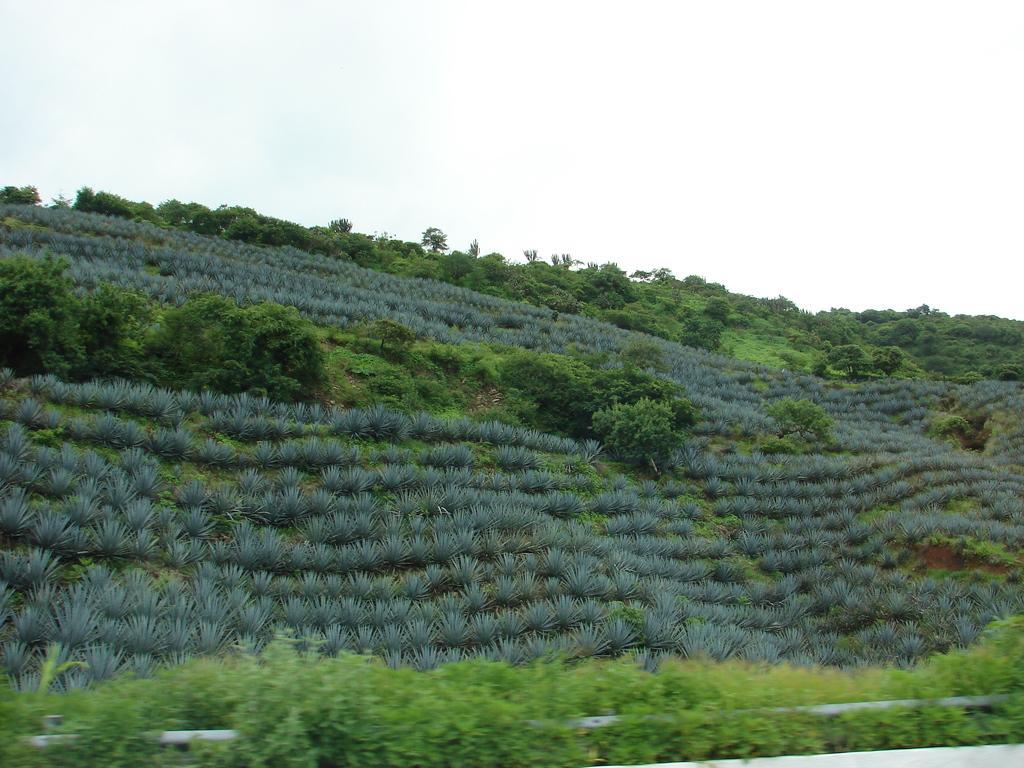Please provide a concise description of this image. In this picture we can see a pipe in between the plants. There are few plants and trees in the background. 